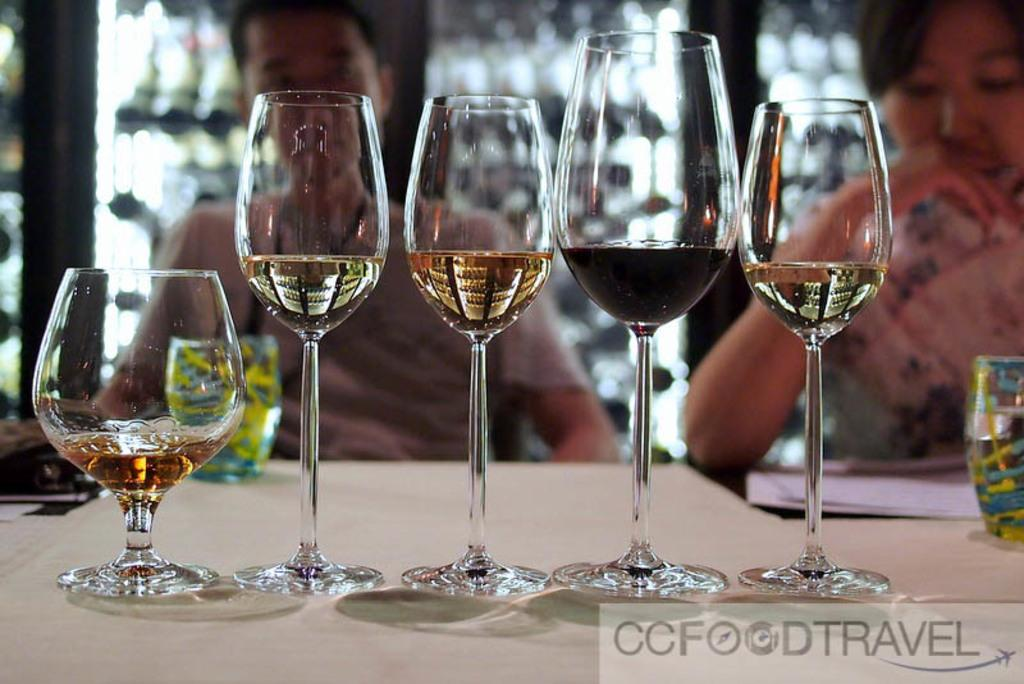How many glasses are on the table in the image? There are seven glasses on the table. What else is on the table besides the glasses? There is a paper sheet on the table. Can you describe the seating arrangement in the background of the image? There are two persons sitting in the background, and they are sitting on chairs. What color of paint is being used by the person in the image? There is no person using paint in the image; it only shows seven glasses on the table and two persons sitting in the background. 